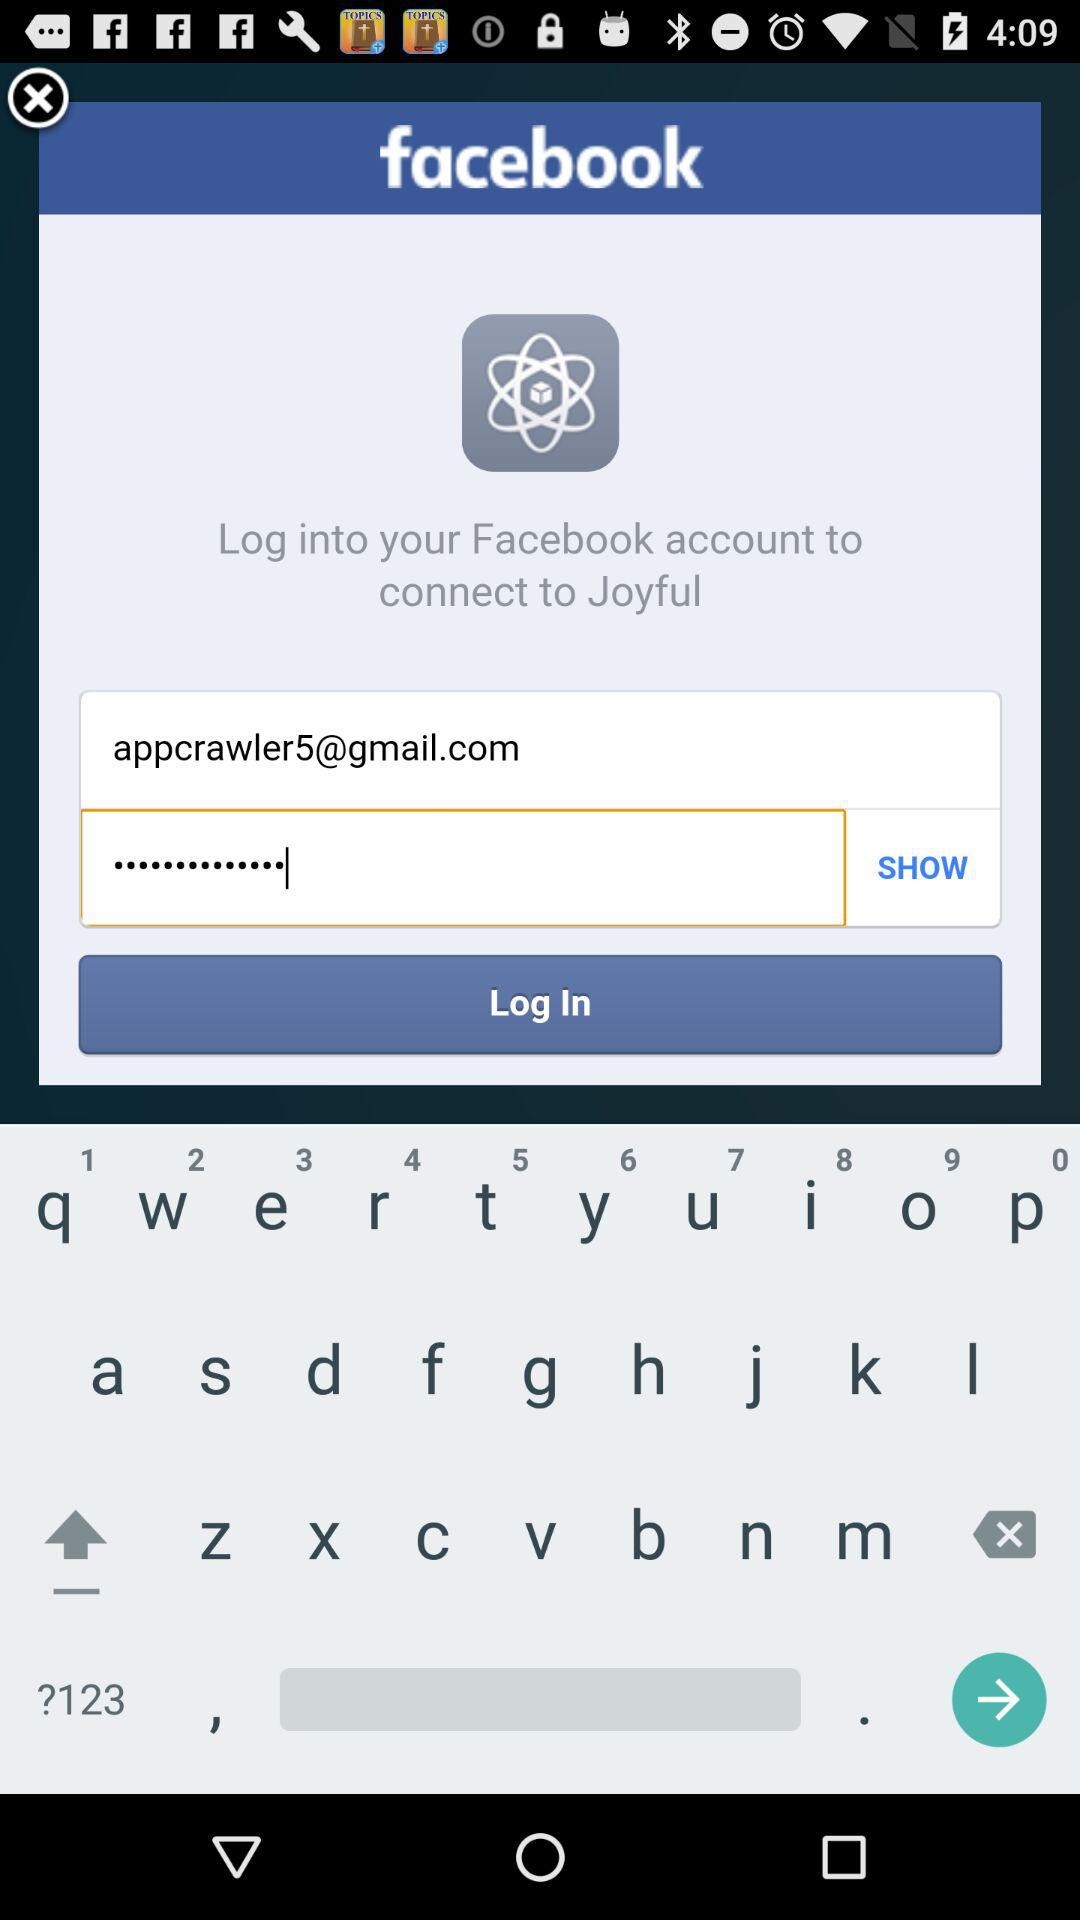What's the Gmail address? The Gmail address is appcrawler5@gmail.com. 